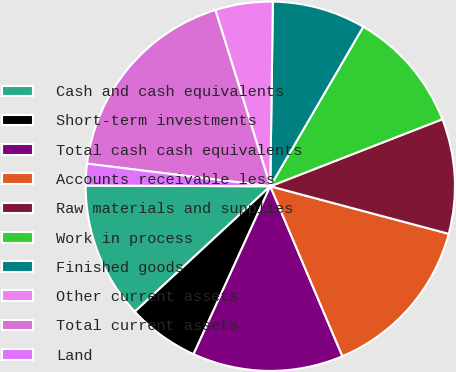Convert chart to OTSL. <chart><loc_0><loc_0><loc_500><loc_500><pie_chart><fcel>Cash and cash equivalents<fcel>Short-term investments<fcel>Total cash cash equivalents<fcel>Accounts receivable less<fcel>Raw materials and supplies<fcel>Work in process<fcel>Finished goods<fcel>Other current assets<fcel>Total current assets<fcel>Land<nl><fcel>11.95%<fcel>6.29%<fcel>13.21%<fcel>14.47%<fcel>10.06%<fcel>10.69%<fcel>8.18%<fcel>5.03%<fcel>18.24%<fcel>1.89%<nl></chart> 